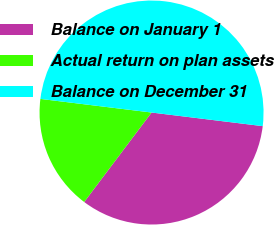<chart> <loc_0><loc_0><loc_500><loc_500><pie_chart><fcel>Balance on January 1<fcel>Actual return on plan assets<fcel>Balance on December 31<nl><fcel>33.33%<fcel>16.67%<fcel>50.0%<nl></chart> 